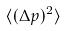Convert formula to latex. <formula><loc_0><loc_0><loc_500><loc_500>\langle ( \Delta p ) ^ { 2 } \rangle</formula> 